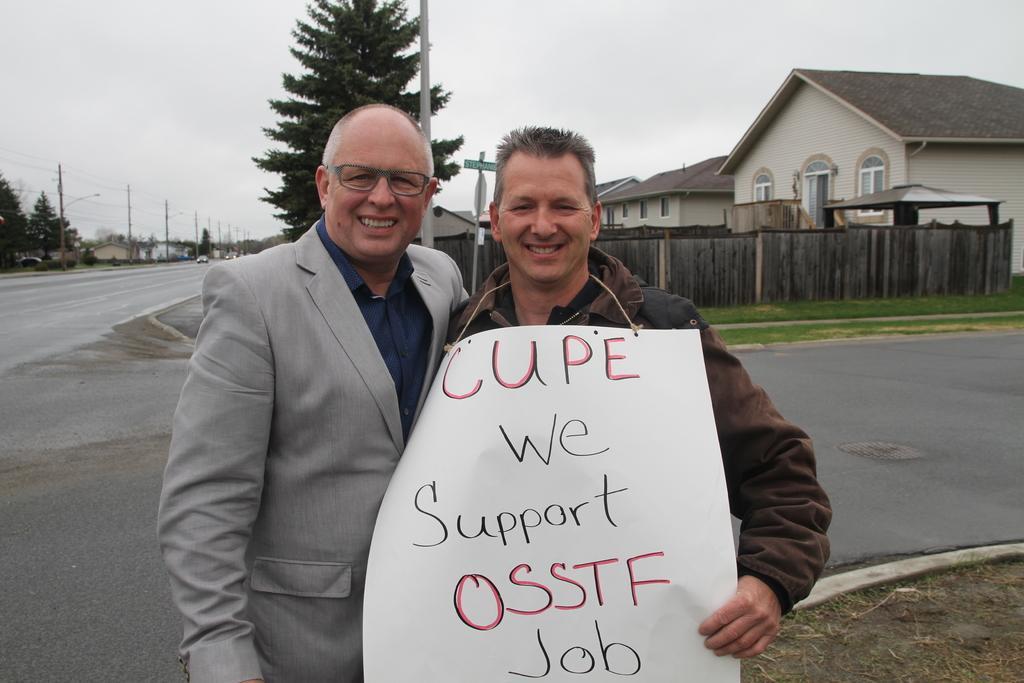In one or two sentences, can you explain what this image depicts? In the picture we can see two men are standing together and smiling and they are holding a white color paper written on it as cupe we support osstf job, behind them we can see a road and some grass surface and a wooden wall and behind it we can see some houses and near the wall we can see a pole and some tree and a road beside it and on the opposite side also we can see some poles, trees and houses and in the background we can see a sky. 